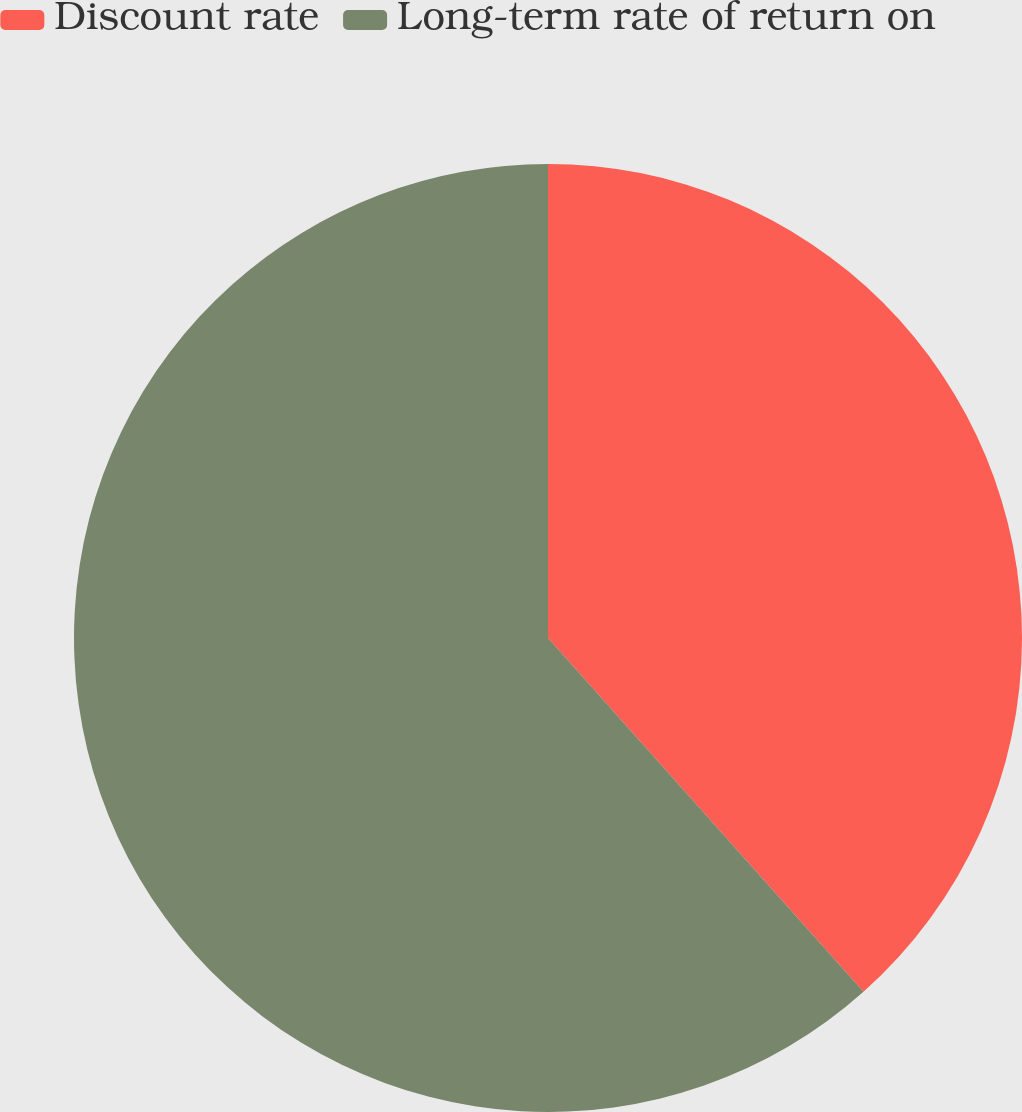Convert chart to OTSL. <chart><loc_0><loc_0><loc_500><loc_500><pie_chart><fcel>Discount rate<fcel>Long-term rate of return on<nl><fcel>38.41%<fcel>61.59%<nl></chart> 